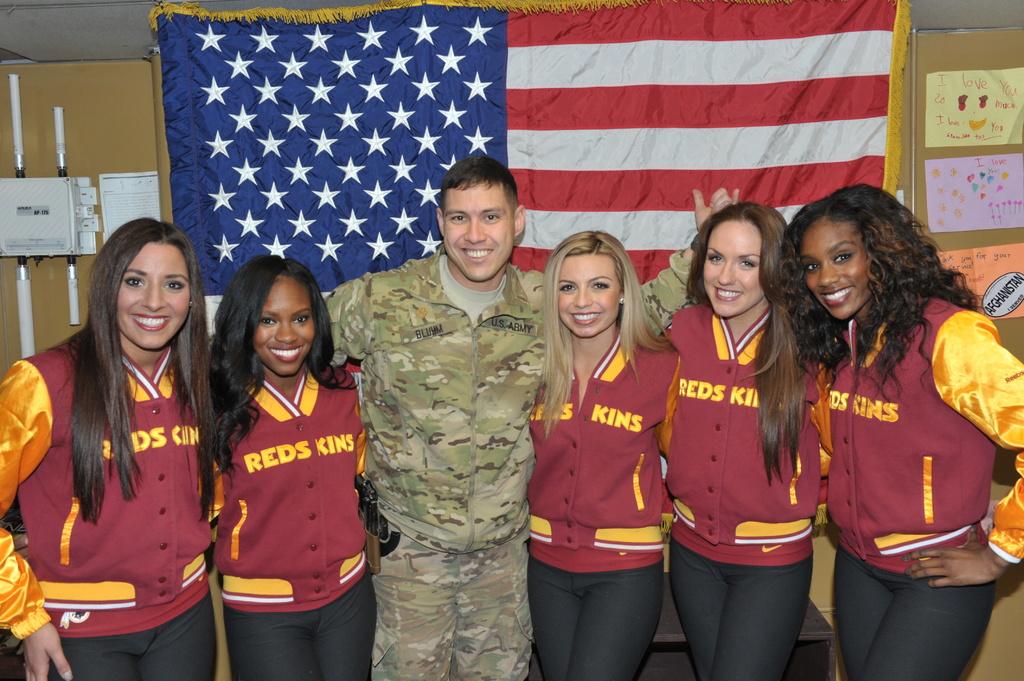What team are these girls probably cheerleaders for?
Keep it short and to the point. Redskins. 